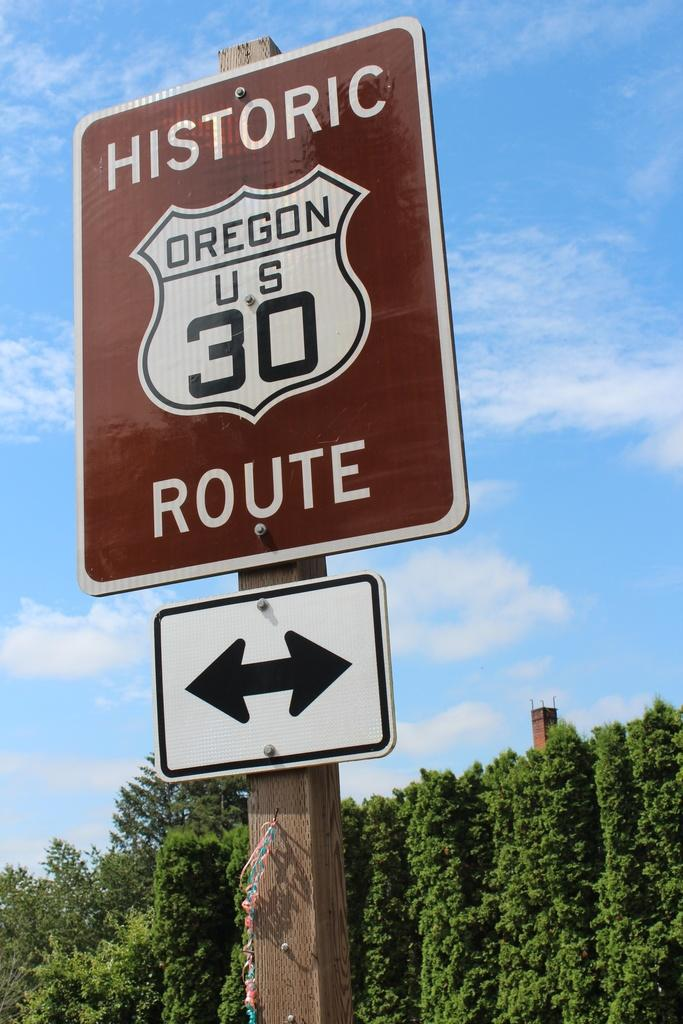Provide a one-sentence caption for the provided image. A sign for Oregen US 30 labeled Historic Route. 